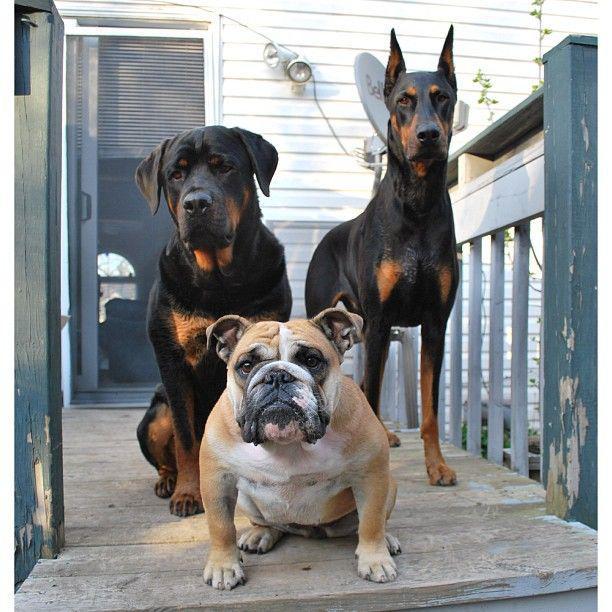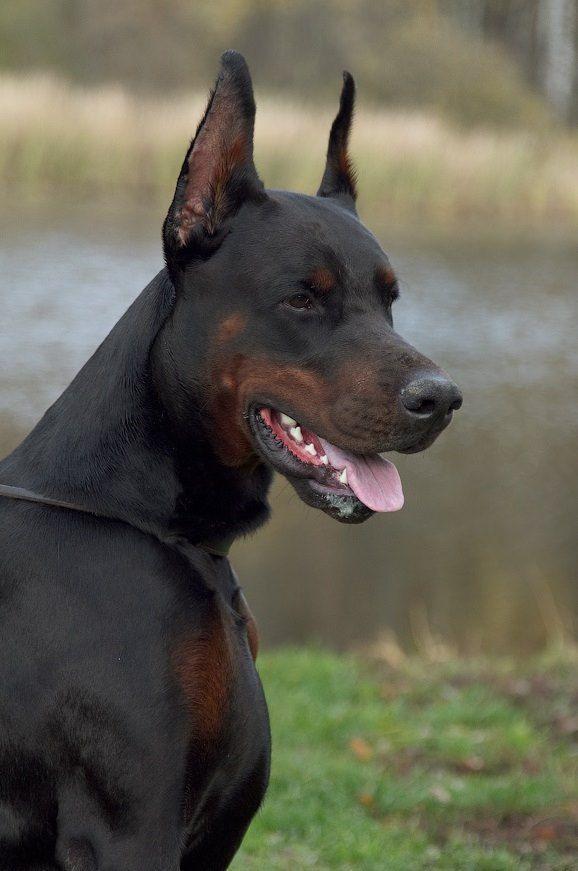The first image is the image on the left, the second image is the image on the right. Assess this claim about the two images: "One picture has only three dogs posing together.". Correct or not? Answer yes or no. Yes. The first image is the image on the left, the second image is the image on the right. Analyze the images presented: Is the assertion "There are exactly five dogs in total." valid? Answer yes or no. No. 